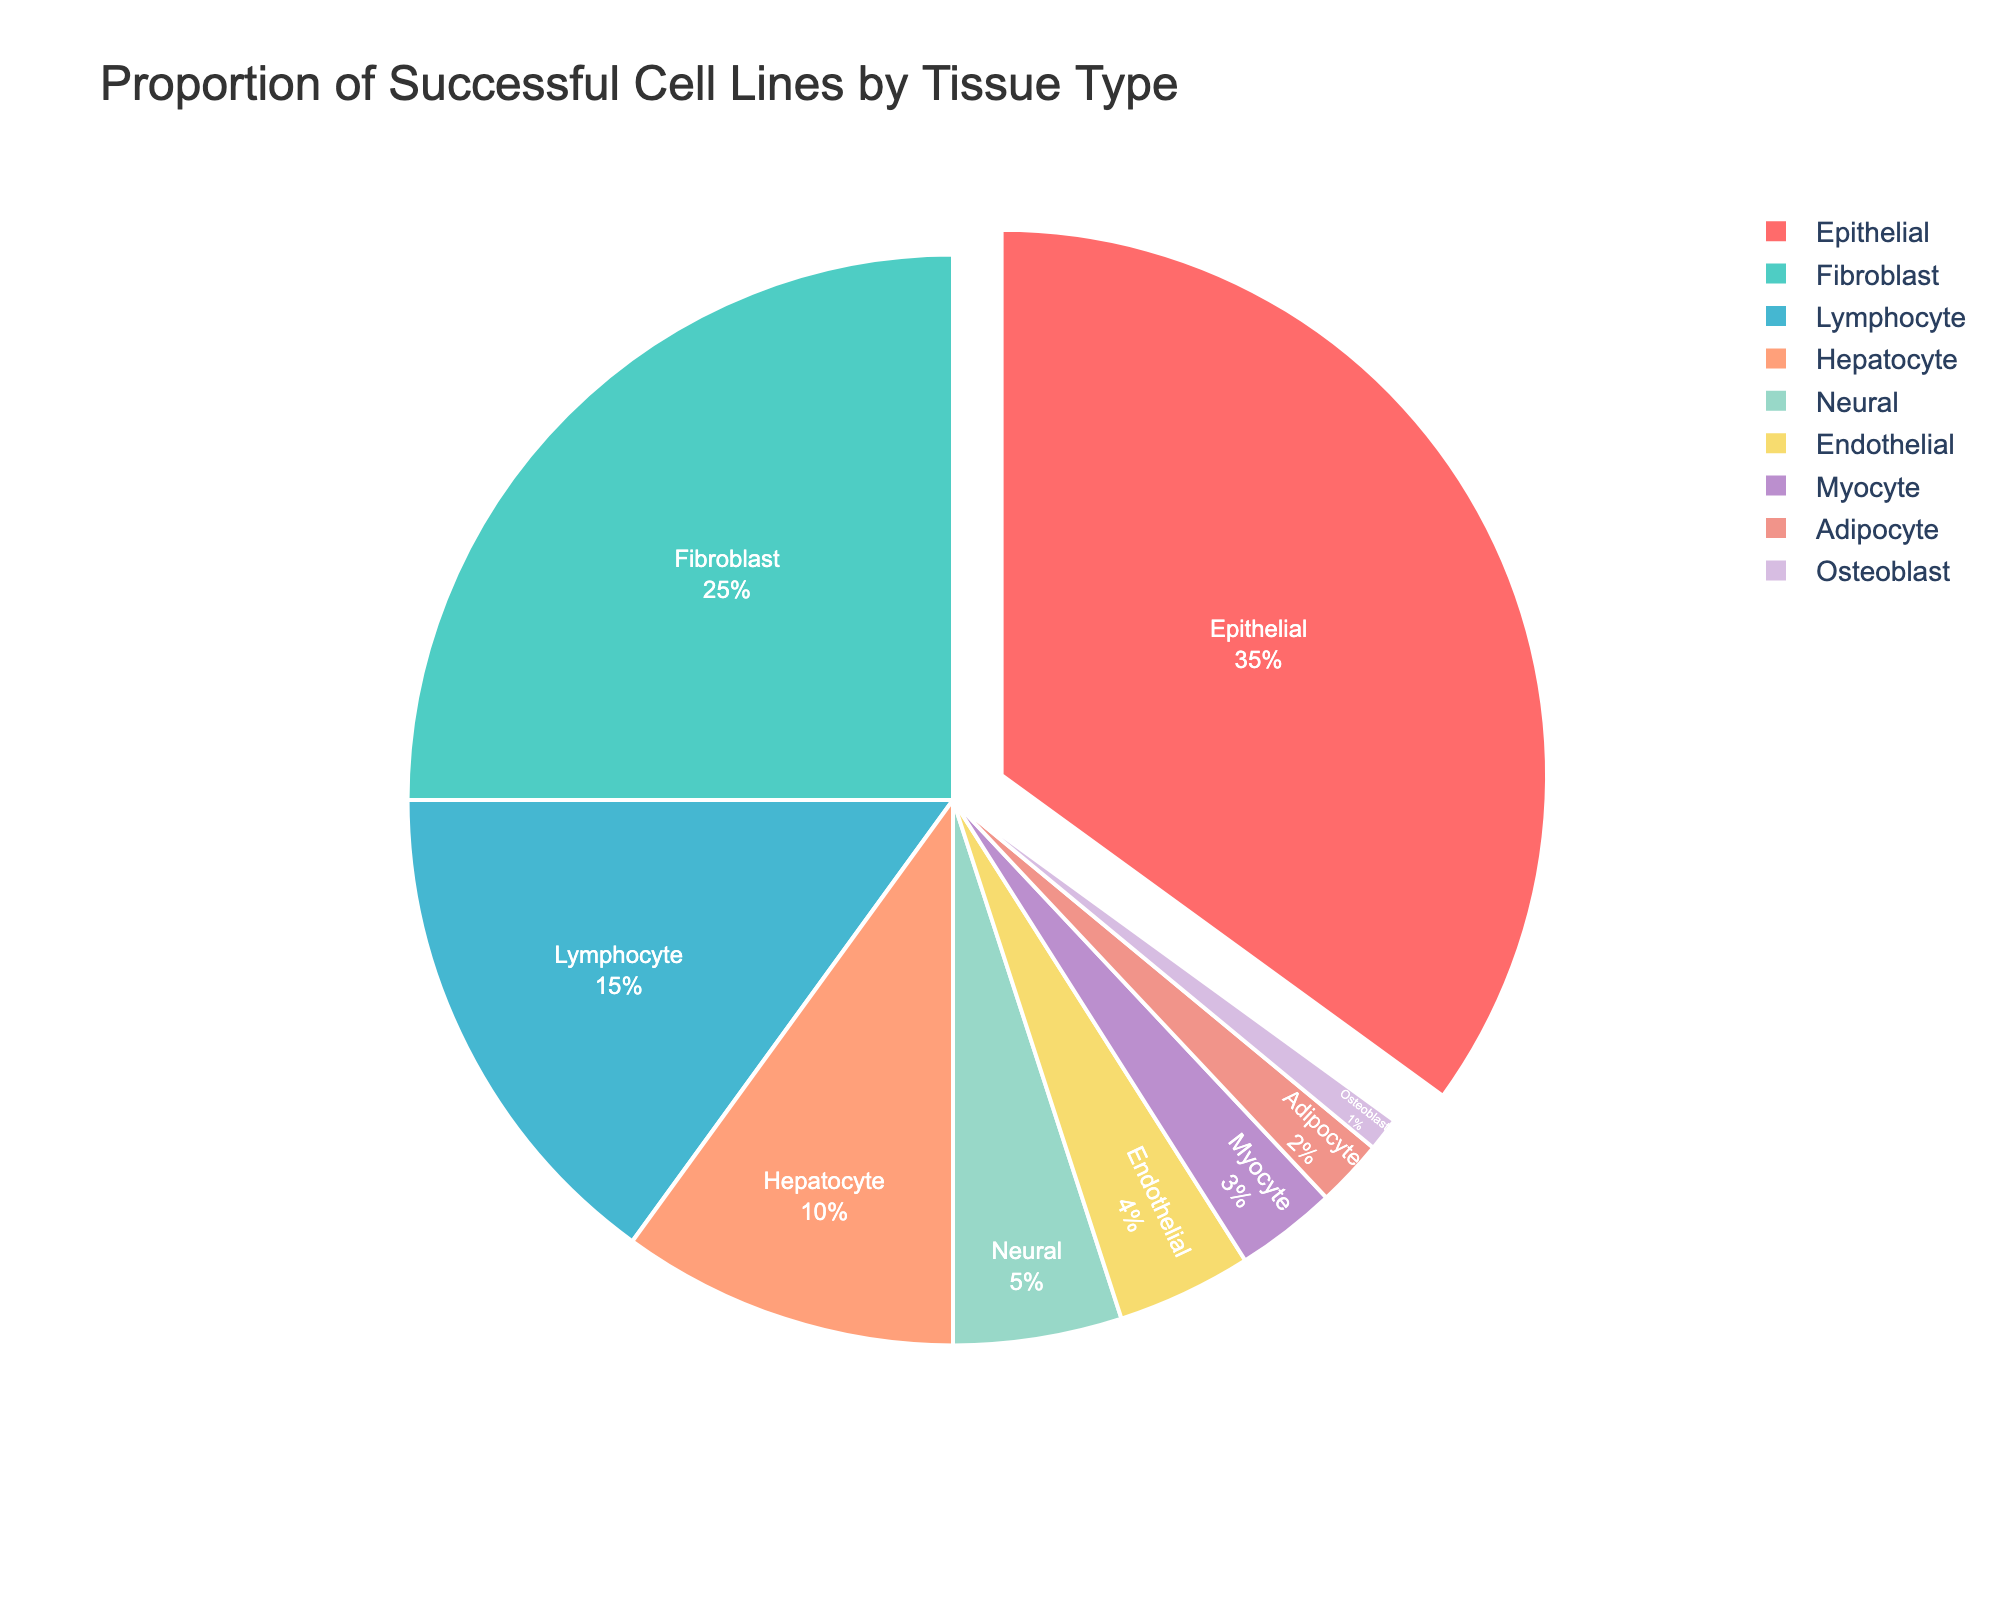What is the proportion of successful cell lines derived from epithelial tissue? Epithelial tissue's proportion is clearly indicated in the pie chart as 35%.
Answer: 35% Which tissue type has the lowest success rate of derived cell lines? By examining the pie chart, it's evident that osteoblasts have the smallest segment.
Answer: Osteoblast How do the success rates of fibroblast and lymphocyte cell lines compare? By visually comparing the two segments, fibroblasts have a larger proportion than lymphocytes.
Answer: Fibroblast > Lymphocyte What is the combined success rate of hepatocyte, neural, and endothelial tissue types? Adding up the success rates: 10% (hepatocyte) + 5% (neural) + 4% (endothelial) = 19%.
Answer: 19% Which tissue type has a success rate twice that of endothelial tissue? Endothelial has a 4% success rate. The tissue with 8% is not present, but fibroblast is closest with a 25% rate.
Answer: None exactly, but fibroblast is closest What is the difference in success rate between myocyte and adipocyte tissue types? The success rate for myocyte is 3%, and for adipocyte, it is 2%. The difference is 3% - 2% = 1%.
Answer: 1% Which tissue type occupies the second largest portion of the pie chart? The segment with the second largest area after epithelial tissue is fibroblast, which is 25%.
Answer: Fibroblast What is the success rate of the tissue type colored red in the pie chart? The red segment in the pie chart corresponds to epithelial tissue, which has a proportion of 35%.
Answer: 35% How many tissue types have a success rate lower than 5%? From the pie chart, neural (5%), endothelial (4%), myocyte (3%), adipocyte (2%), and osteoblast (1%) are less than 5%.
Answer: 5 